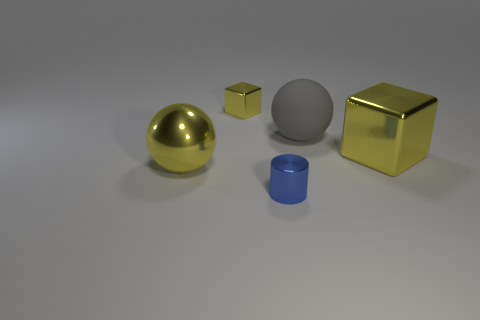What materials are represented by the objects in the image? The objects in the image seem to illustrate different materials. The sphere on the left has a reflective gold finish suggesting a metallic material, whereas the central cube appears to have a matte, possibly plastic surface. The cylinder has a metallic sheen which likely indicates a metallic material as well, and the cube to the right displays a reflective surface, similar to polished gold or metal. 